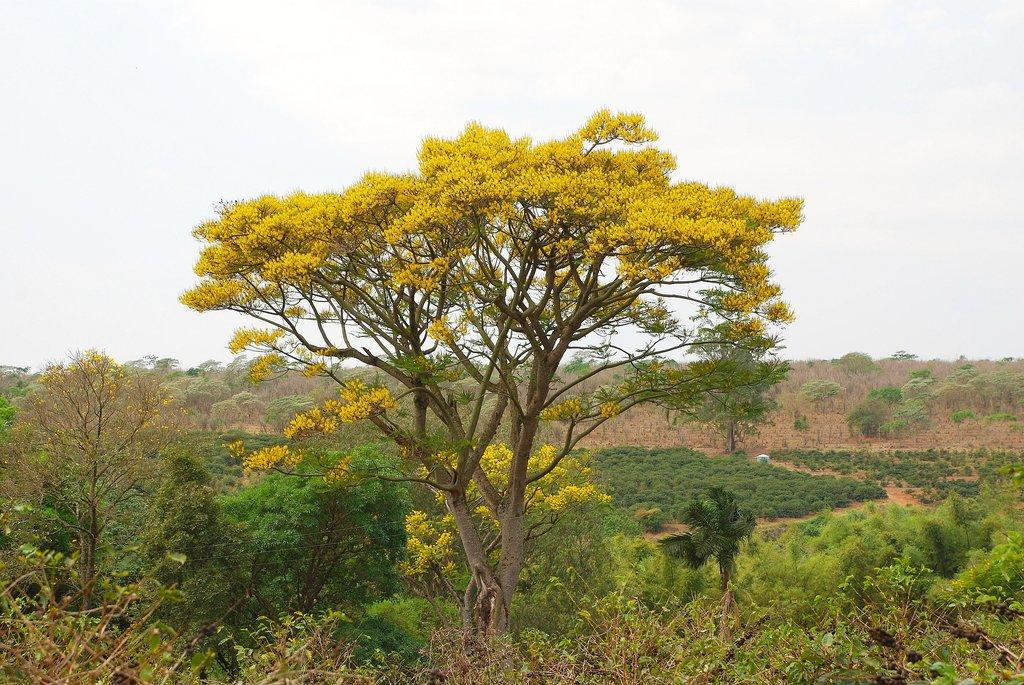What type of vegetation can be seen in the image? There are flowers, trees, and plants in the image. What part of the natural environment is visible in the image? The sky is visible in the image. What day of the week is depicted in the image? There is no specific day of the week depicted in the image, as it features natural elements such as flowers, trees, plants, and the sky. 